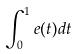<formula> <loc_0><loc_0><loc_500><loc_500>\int _ { 0 } ^ { 1 } e ( t ) d t</formula> 